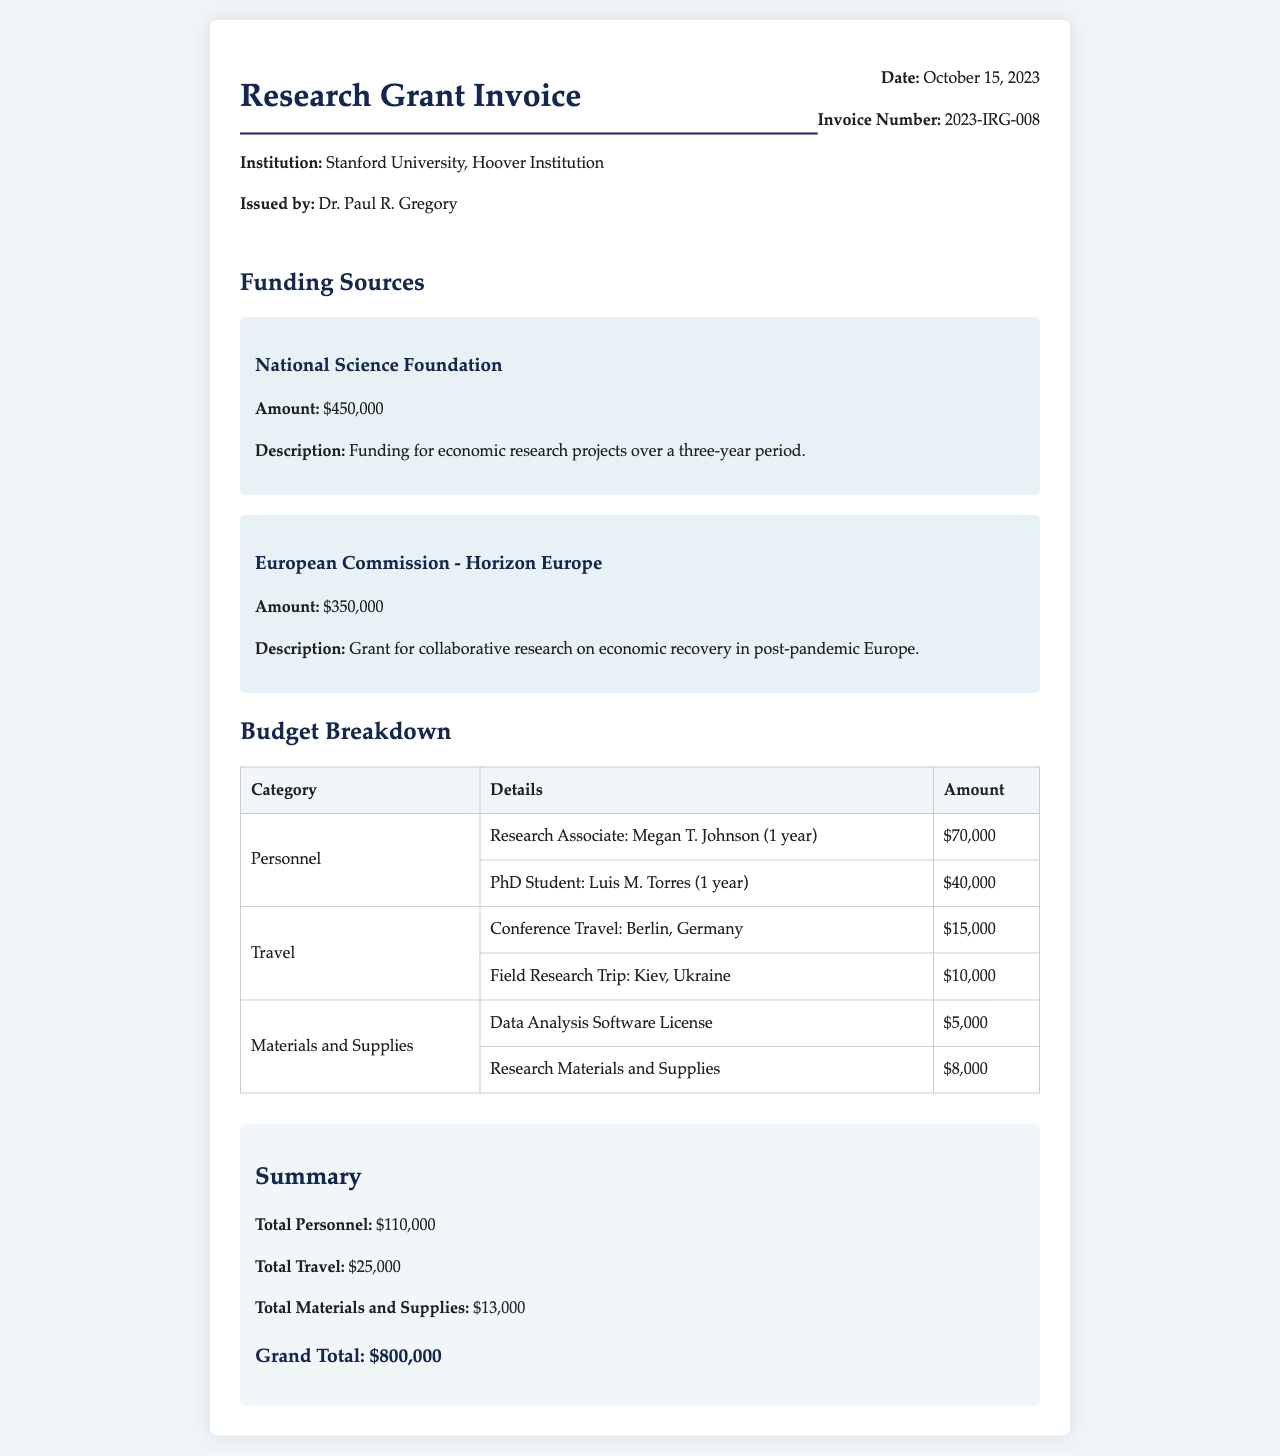What is the institution associated with the invoice? The institution is mentioned in the header as Stanford University, Hoover Institution.
Answer: Stanford University, Hoover Institution What is the total amount of funding from the National Science Foundation? The document lists the funding amount from the National Science Foundation as $450,000.
Answer: $450,000 Who is the Research Associate listed in the personnel section? The name of the Research Associate is provided as Megan T. Johnson.
Answer: Megan T. Johnson What is the cost for travel to Berlin, Germany? The invoice states the cost for Conference Travel to Berlin, Germany is $15,000.
Answer: $15,000 What is the total amount allocated for personnel expenses? The total personnel expenses are calculated by adding Megan T. Johnson's and Luis M. Torres' salaries, which is $70,000 + $40,000 = $110,000.
Answer: $110,000 What is the total funding amount listed in the document? The grand total is summarized at the end of the document and amounts to $800,000.
Answer: $800,000 How many PhD students are mentioned in the personnel section? The document mentions one PhD student, Luis M. Torres.
Answer: One What was the purpose of the grant from the European Commission? The document describes the purpose of the grant as collaborative research on economic recovery in post-pandemic Europe.
Answer: Collaborative research on economic recovery in post-pandemic Europe What is the total amount spent on materials and supplies? The total for materials and supplies is given as $13,000 in the summary section.
Answer: $13,000 